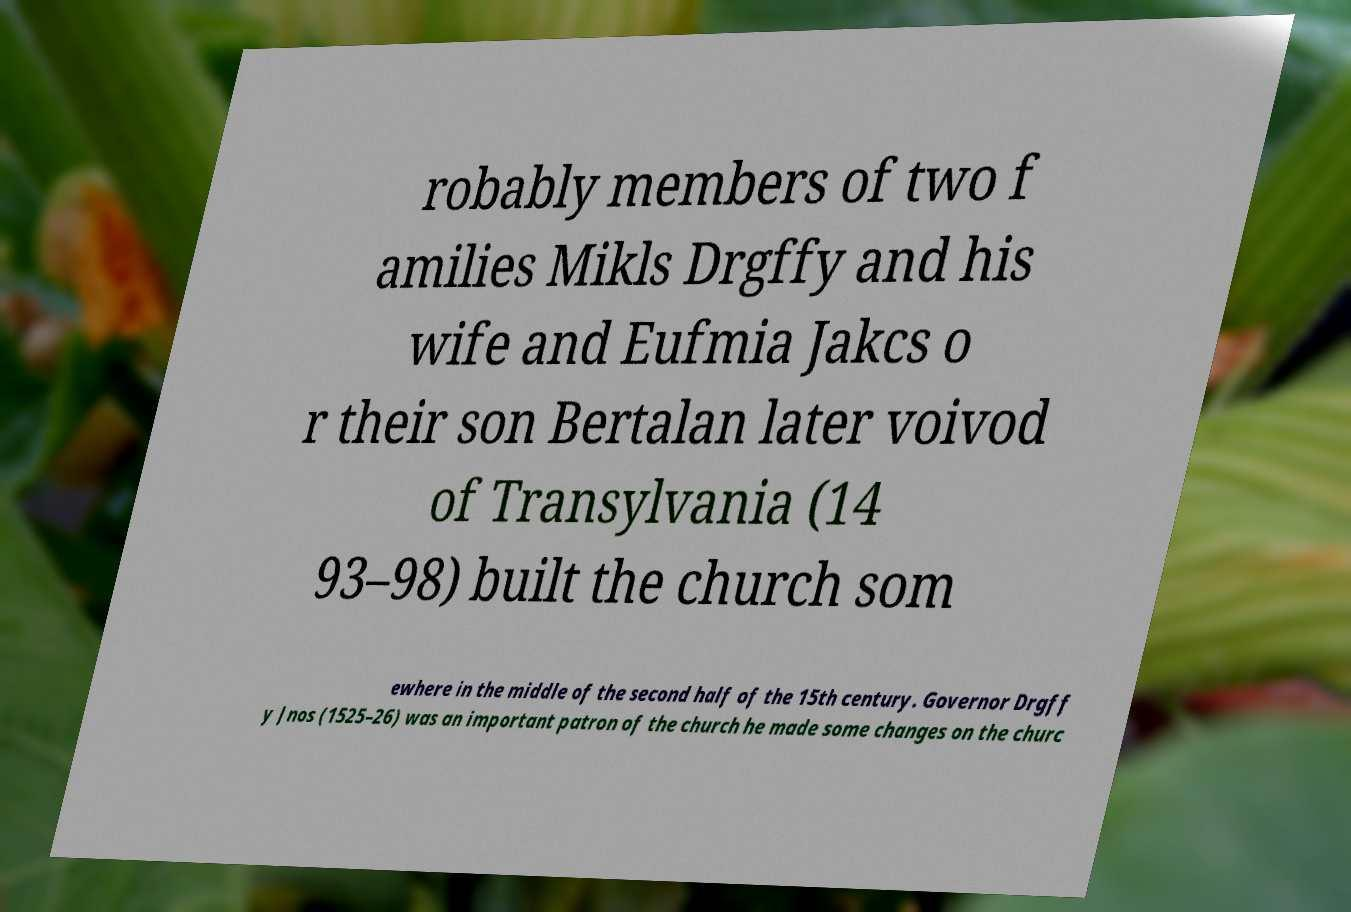What messages or text are displayed in this image? I need them in a readable, typed format. robably members of two f amilies Mikls Drgffy and his wife and Eufmia Jakcs o r their son Bertalan later voivod of Transylvania (14 93–98) built the church som ewhere in the middle of the second half of the 15th century. Governor Drgff y Jnos (1525–26) was an important patron of the church he made some changes on the churc 